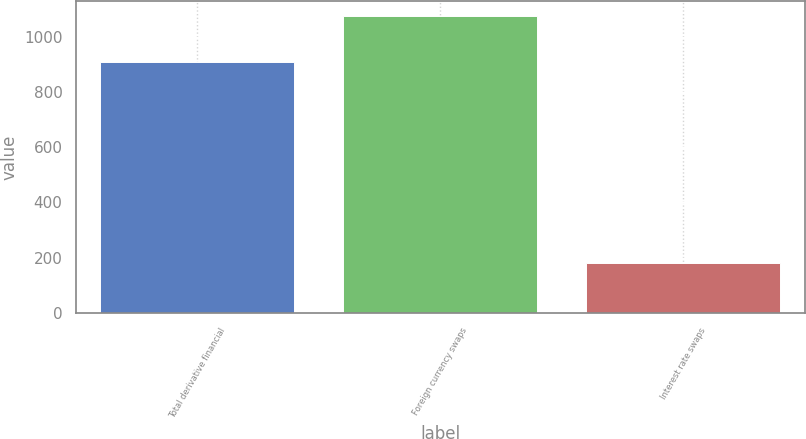<chart> <loc_0><loc_0><loc_500><loc_500><bar_chart><fcel>Total derivative financial<fcel>Foreign currency swaps<fcel>Interest rate swaps<nl><fcel>911<fcel>1076<fcel>180<nl></chart> 